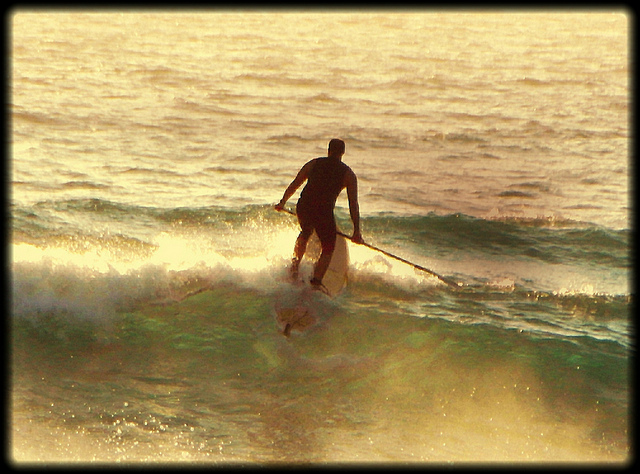What could be the potential challenges the man might face while paddleboarding? While paddleboarding, the man might face several challenges, including maintaining balance, especially if the water becomes choppy. He must be able to navigate through the waves and avoid any obstacles like rocks or marine life. Wind and current conditions can also make it difficult to control his direction and speed. Furthermore, fatigue from paddling and constant balancing can set in over long periods. Can you elaborate on the skills needed for successful paddleboarding? Successful paddleboarding requires a combination of physical and mental skills. Physically, core strength and balance are crucial for staying upright and maneuvering the board. Strong paddling techniques involve using the whole body, not just the arms, to avoid fatigue. Mentally, good situational awareness is needed to navigate safely, assess wave and weather conditions, and respond to any changes quickly. Patience and persistence also help beginners master the nuances of paddleboarding. 